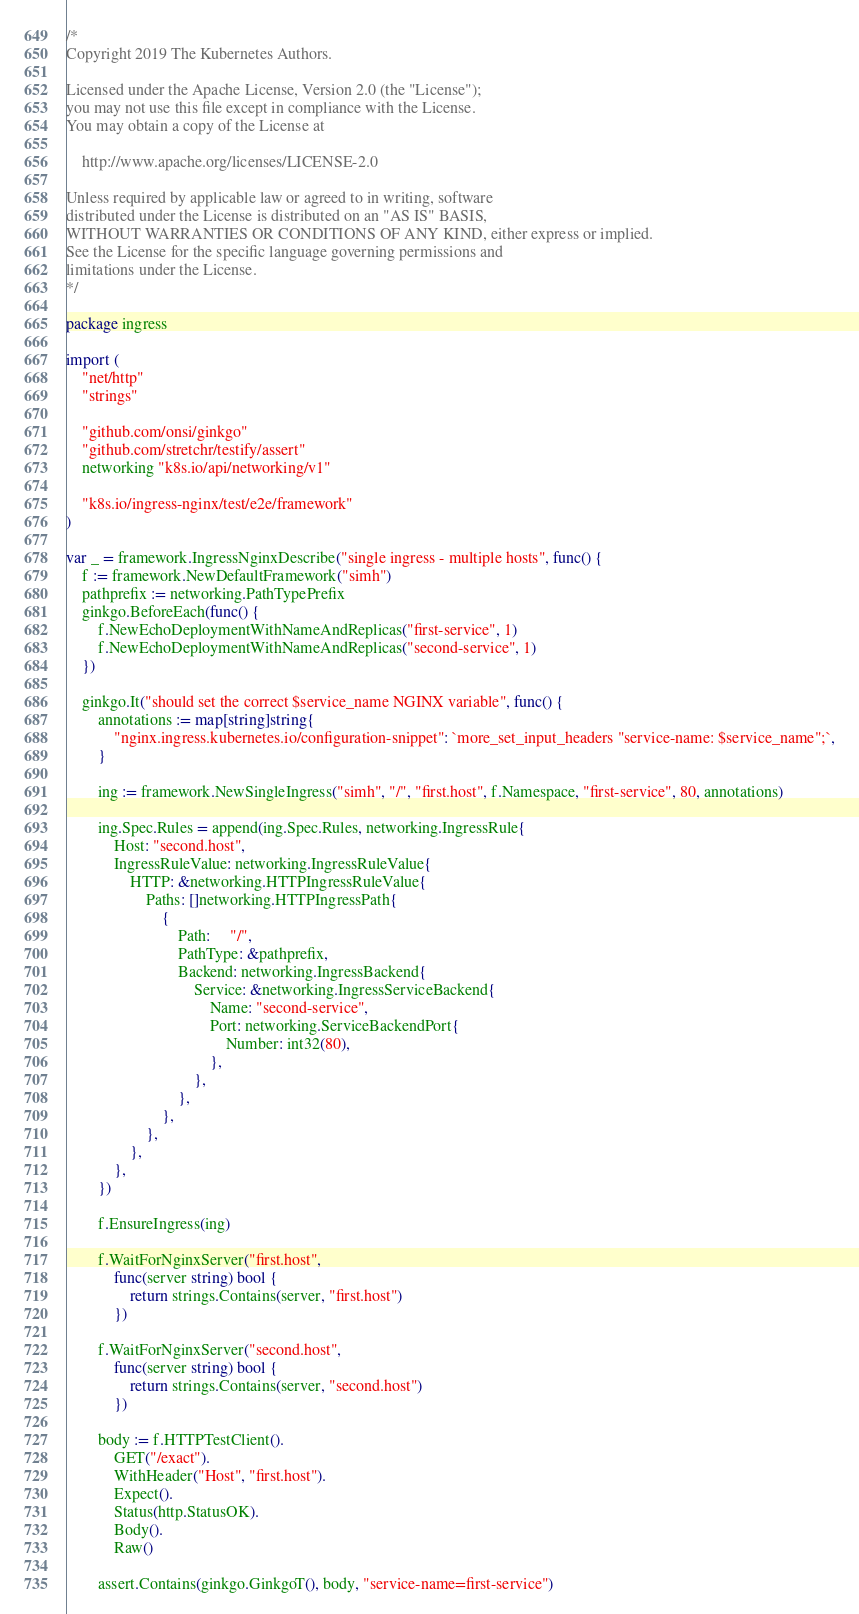Convert code to text. <code><loc_0><loc_0><loc_500><loc_500><_Go_>/*
Copyright 2019 The Kubernetes Authors.

Licensed under the Apache License, Version 2.0 (the "License");
you may not use this file except in compliance with the License.
You may obtain a copy of the License at

    http://www.apache.org/licenses/LICENSE-2.0

Unless required by applicable law or agreed to in writing, software
distributed under the License is distributed on an "AS IS" BASIS,
WITHOUT WARRANTIES OR CONDITIONS OF ANY KIND, either express or implied.
See the License for the specific language governing permissions and
limitations under the License.
*/

package ingress

import (
	"net/http"
	"strings"

	"github.com/onsi/ginkgo"
	"github.com/stretchr/testify/assert"
	networking "k8s.io/api/networking/v1"

	"k8s.io/ingress-nginx/test/e2e/framework"
)

var _ = framework.IngressNginxDescribe("single ingress - multiple hosts", func() {
	f := framework.NewDefaultFramework("simh")
	pathprefix := networking.PathTypePrefix
	ginkgo.BeforeEach(func() {
		f.NewEchoDeploymentWithNameAndReplicas("first-service", 1)
		f.NewEchoDeploymentWithNameAndReplicas("second-service", 1)
	})

	ginkgo.It("should set the correct $service_name NGINX variable", func() {
		annotations := map[string]string{
			"nginx.ingress.kubernetes.io/configuration-snippet": `more_set_input_headers "service-name: $service_name";`,
		}

		ing := framework.NewSingleIngress("simh", "/", "first.host", f.Namespace, "first-service", 80, annotations)

		ing.Spec.Rules = append(ing.Spec.Rules, networking.IngressRule{
			Host: "second.host",
			IngressRuleValue: networking.IngressRuleValue{
				HTTP: &networking.HTTPIngressRuleValue{
					Paths: []networking.HTTPIngressPath{
						{
							Path:     "/",
							PathType: &pathprefix,
							Backend: networking.IngressBackend{
								Service: &networking.IngressServiceBackend{
									Name: "second-service",
									Port: networking.ServiceBackendPort{
										Number: int32(80),
									},
								},
							},
						},
					},
				},
			},
		})

		f.EnsureIngress(ing)

		f.WaitForNginxServer("first.host",
			func(server string) bool {
				return strings.Contains(server, "first.host")
			})

		f.WaitForNginxServer("second.host",
			func(server string) bool {
				return strings.Contains(server, "second.host")
			})

		body := f.HTTPTestClient().
			GET("/exact").
			WithHeader("Host", "first.host").
			Expect().
			Status(http.StatusOK).
			Body().
			Raw()

		assert.Contains(ginkgo.GinkgoT(), body, "service-name=first-service")</code> 